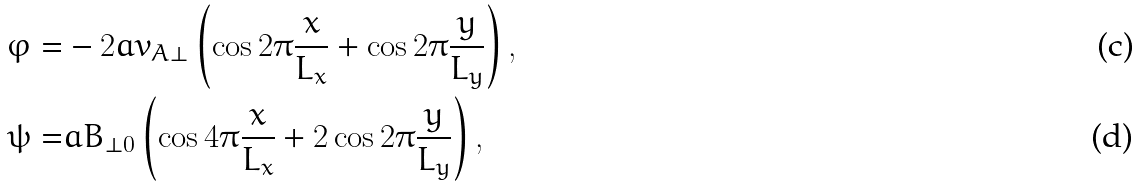Convert formula to latex. <formula><loc_0><loc_0><loc_500><loc_500>\varphi = & - 2 a v _ { A \perp } \left ( \cos 2 \pi \frac { x } { L _ { x } } + \cos 2 \pi \frac { y } { L _ { y } } \right ) , \\ \psi = & a B _ { \perp 0 } \left ( \cos 4 \pi \frac { x } { L _ { x } } + 2 \cos 2 \pi \frac { y } { L _ { y } } \right ) ,</formula> 